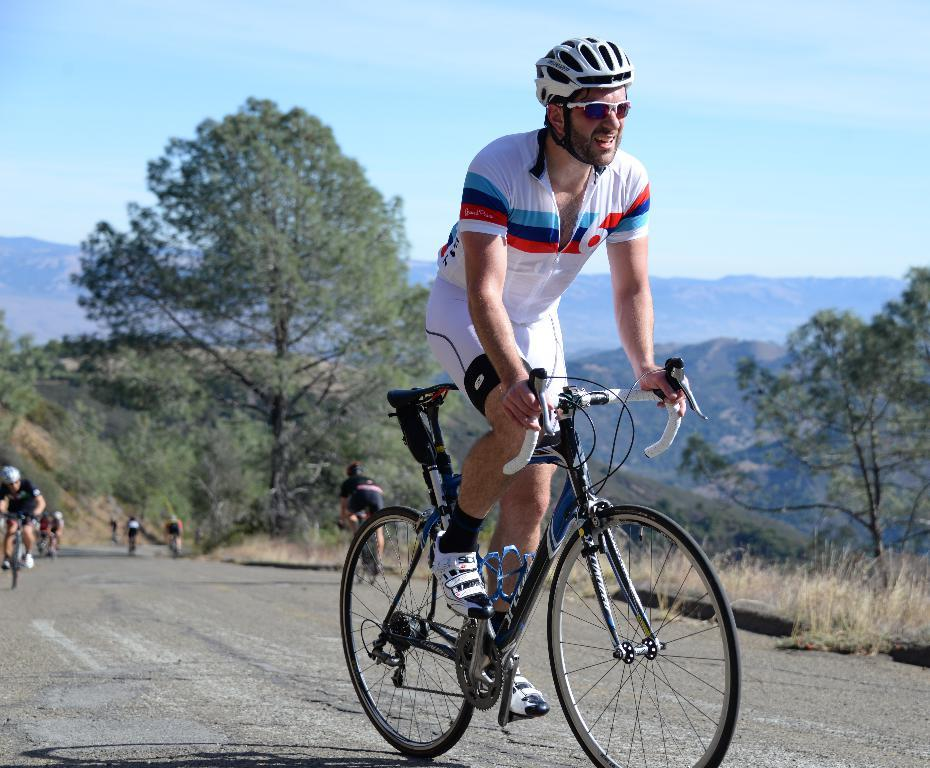What type of natural formation can be seen in the image? There are mountains in the image. What are the people in the image doing? The people in the image are riding bicycles on the road. What type of vegetation is present in the image? There are trees, bushes, plants, and grass in the image. What is visible at the top of the image? The sky is visible at the top of the image. Can you tell me how many earthquakes occurred in the image? There is no mention of an earthquake in the image; it features mountains, people riding bicycles, and various types of vegetation. Is there a writer present in the image? There is no writer present in the image; it features mountains, people riding bicycles, and various types of vegetation. 